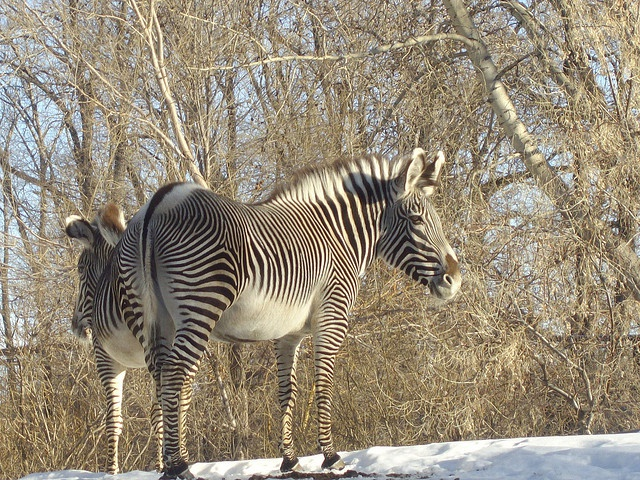Describe the objects in this image and their specific colors. I can see zebra in lightgray, gray, black, and darkgray tones and zebra in lightgray, gray, and black tones in this image. 